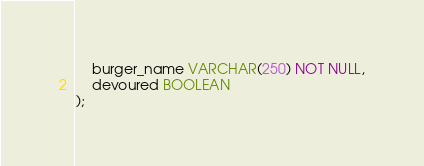<code> <loc_0><loc_0><loc_500><loc_500><_SQL_>    burger_name VARCHAR(250) NOT NULL,
    devoured BOOLEAN
);</code> 